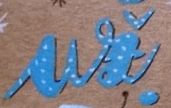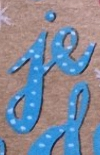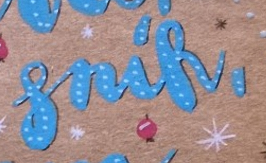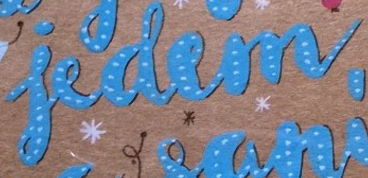What words can you see in these images in sequence, separated by a semicolon? ui; je; snik,; iedem 